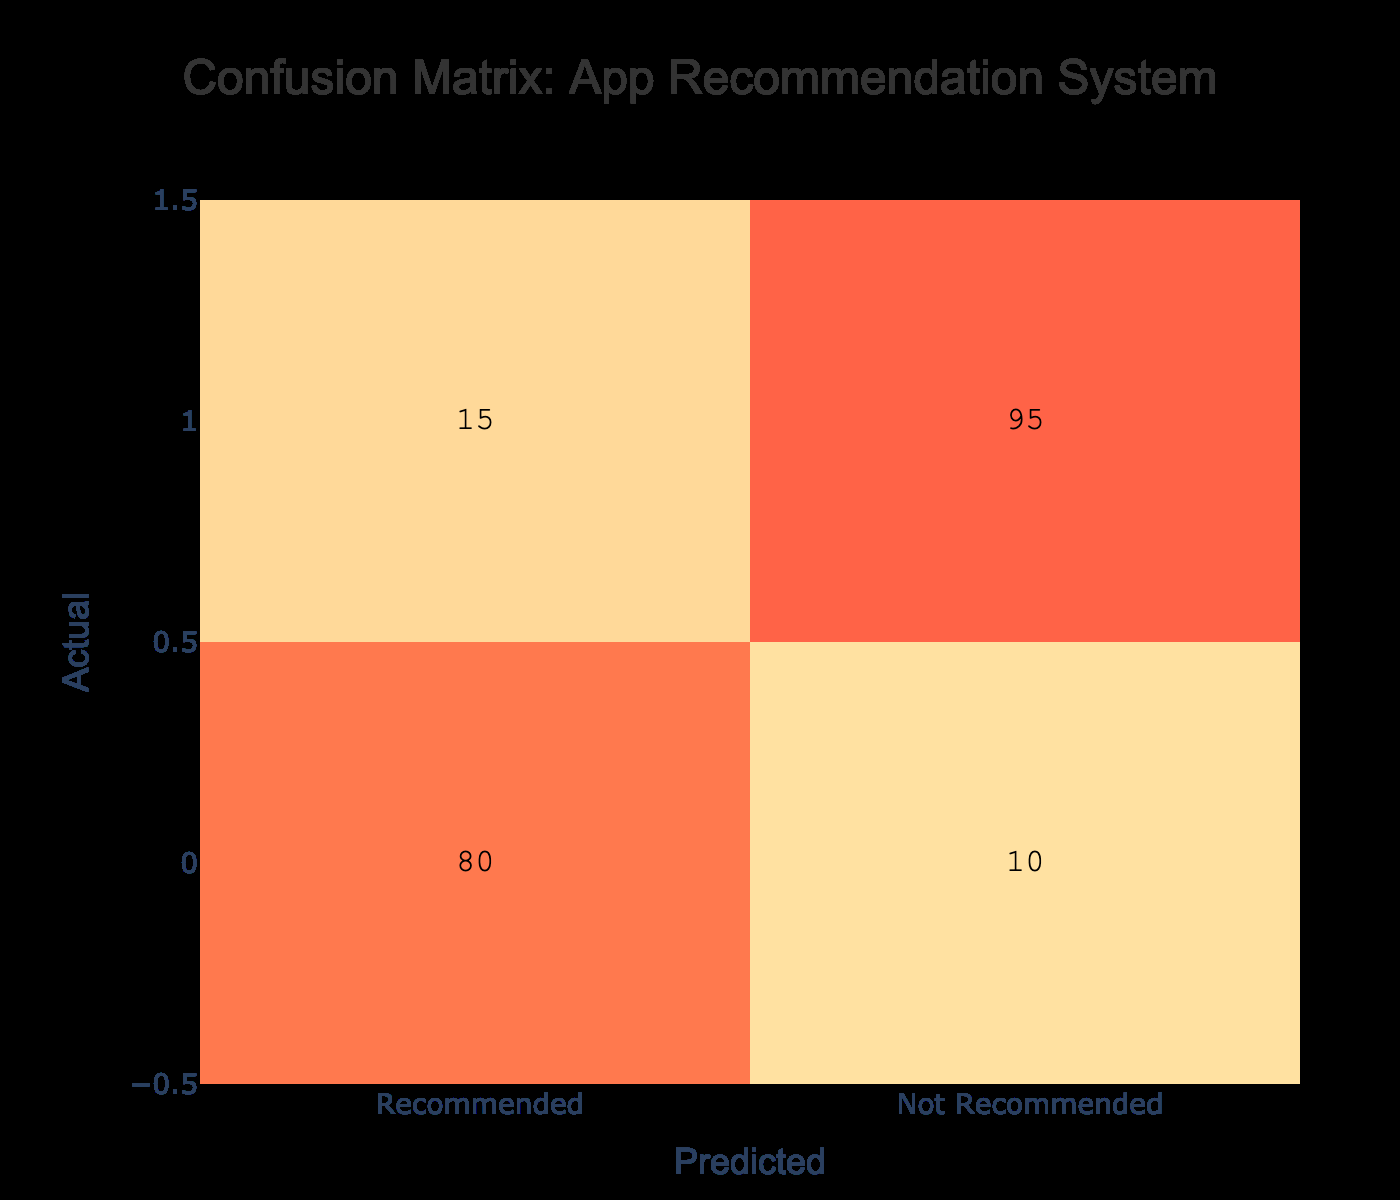What is the total number of instances where apps were recommended? To find the total recommended instances, we look at the "Recommended" row and sum its values: 80 (true positives) + 10 (false positives) = 90.
Answer: 90 How many applications were predicted as "Not Recommended" but were actually "Recommended"? This is represented by the cell under the "Not Recommended" column in the "Recommended" row, which is 10.
Answer: 10 What percentage of actual "Not Recommended" cases were predicted correctly? To find this percentage, we take the value for "Not Recommended" predicted correctly (95) and divide it by the total actual "Not Recommended" cases (95 + 15 = 110). This gives us 95/110 = 0.8636, which is approximately 86.36%.
Answer: 86.36% Is it true that more apps were predicted as "Recommended" than "Not Recommended"? From the table, we observe that 90 apps were predicted as "Recommended" while only 55 (10 + 45) apps were predicted as "Not Recommended". Therefore, it is true.
Answer: Yes What is the difference between the number of actual "Recommended" and "Not Recommended" cases? The actual "Recommended" cases total 80 and the "Not Recommended" cases total 110. The difference is calculated as 110 - 80 = 30.
Answer: 30 How many total instances were there in the "Recommended" category of the confusion matrix? From the table, the total instances for the "Recommended" category includes both true positives and false positives: 80 + 10 = 90.
Answer: 90 What is the ratio of true positives to total predictions for "Recommended"? The true positives are 80, and the total predictions for "Recommended" are 90. Therefore, the ratio is 80:90, which simplifies to 8:9.
Answer: 8:9 How many apps were correctly identified as "Recommended"? The number of apps correctly identified is directly given by the true positives, which is 80.
Answer: 80 What is the average value of true positives and false negatives combined? First, we add the true positives (80) and false negatives (15). The total is 95. To get the average, we divide by the number of categories (2), so 95/2 = 47.5.
Answer: 47.5 What fraction of total predictions were incorrect predictions in the "Recommended" category? To find this fraction, we first calculate the total incorrect predictions: 10 (false positives) + 15 (false negatives) = 25. The total predictions is 90. The fraction of incorrect predictions is 25/90, which simplifies to 5/18.
Answer: 5/18 